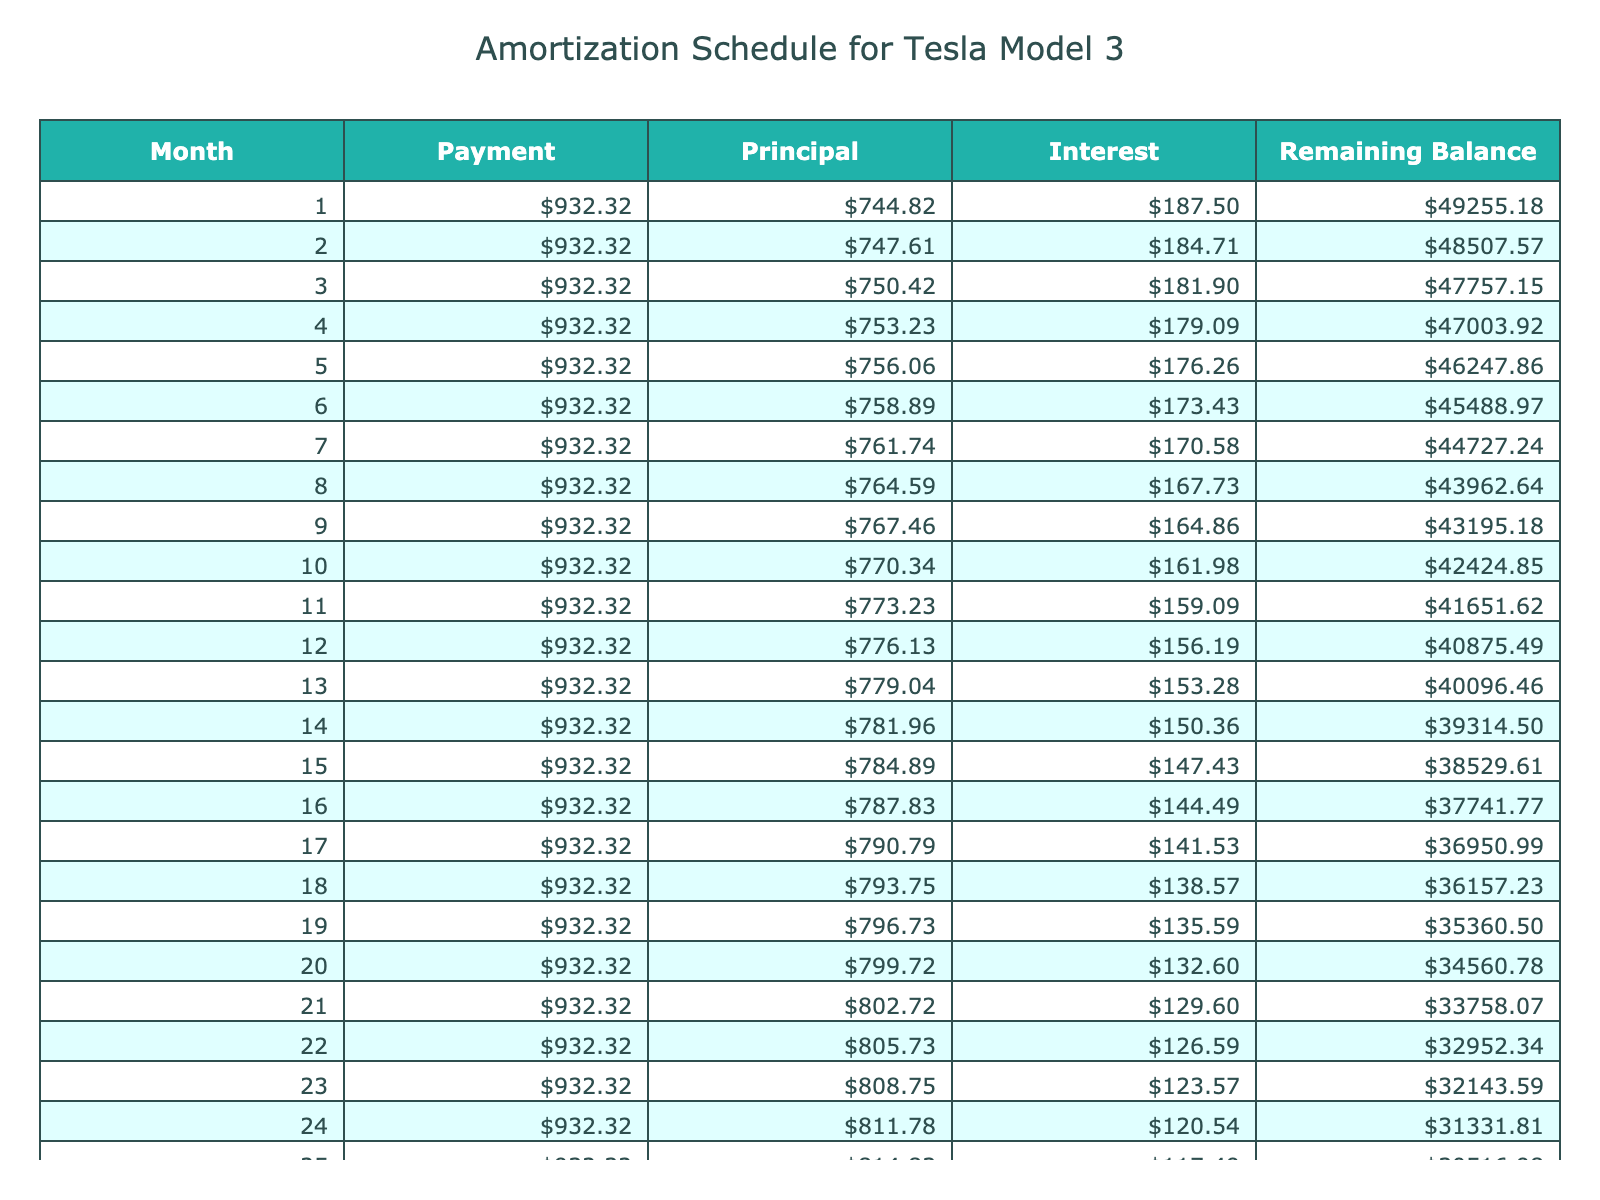What is the monthly payment for the loan? The monthly payment is given in the table under the "Payment" column for all months, and it shows a consistent value. The value listed is 932.32.
Answer: 932.32 What is the total interest paid over the life of the loan? The total interest paid can be found in the "Total Interest" row, which shows the amount paid over the entire term. It is described as 5939.20.
Answer: 5939.20 Is the total payment greater than the loan amount? To determine this, we compare the "Total Payment" value with the "Loan Amount," where the total payment is 55939.20 and the loan amount is 50000. Since 55939.20 is greater than 50000, the statement is true.
Answer: Yes What is the remaining balance after the first month? The remaining balance after the first month needs to be calculated. The table would show the balance for the first month, which is calculated by deducting the principal repayment from the loan amount. The result is available in the table and shows a remaining balance at the end of the first month.
Answer: 49464.68 How much principal is paid in the last month of the loan? To find this, we look at the "Principal" column in the last month, which will provide the exact amount paid in the final payment. The last month will show a figure in the principal section.
Answer: 932.32 What is the average monthly payment over the loan term? The monthly payment is constant across the term. Therefore, this is simply the monthly payment amount, which is 932.32. As there are 60 months, the average remains the same as the monthly payment.
Answer: 932.32 What is the total payment made by the end of the loan term? The "Total Payment" column provides the combined total that will be paid by the end of the loan. This figure is directly available in the table for reference, listed as 55939.20.
Answer: 55939.20 Was any month paid less than the other months? All monthly payments are the same amount paid consistently throughout the term of the loan, as shown in the "Payment" column for all months. Therefore, the answer is no.
Answer: No How much is the interest paid in the first month? The interest paid in the first month is noted in the table under the "Interest" column for that month. The calculation for the first month shows interest at 187.50.
Answer: 187.50 